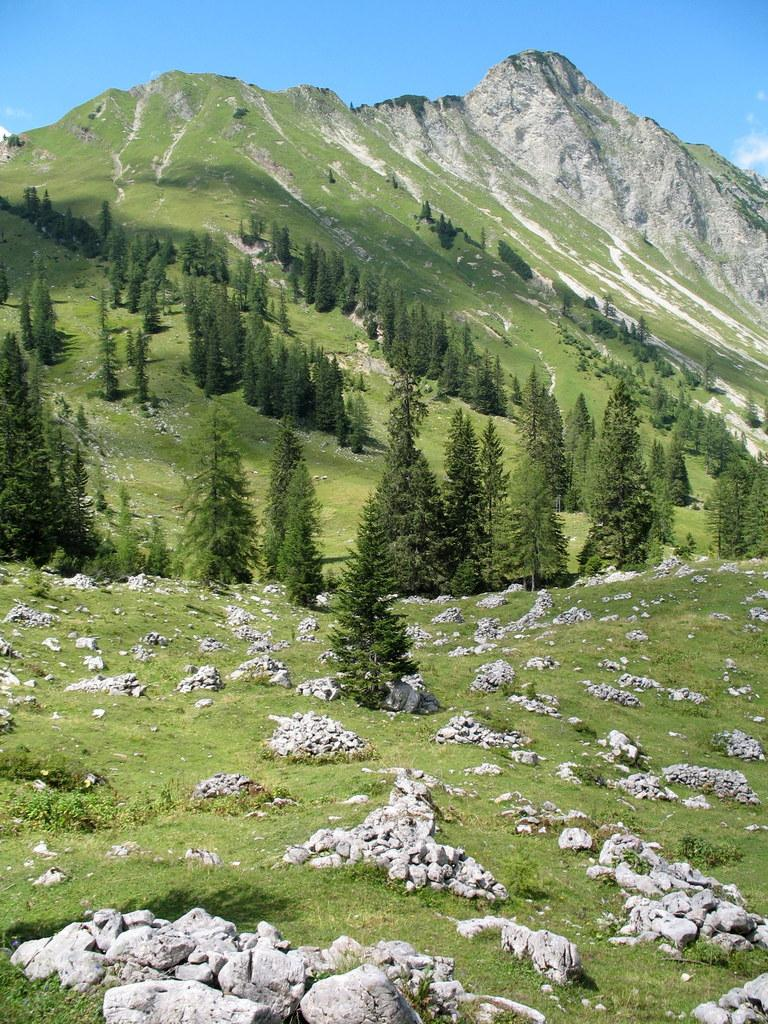What type of vegetation can be seen in the image? There are trees in the image. What other natural elements are present in the image? There are stones and grass visible in the image. What is the largest geographical feature in the image? There is a mountain in the image. What can be seen above the mountain and trees in the image? The sky is visible in the image. What type of steel structure can be seen in the image? There is no steel structure present in the image. How many people are in the group depicted in the image? There is no group of people depicted in the image. 